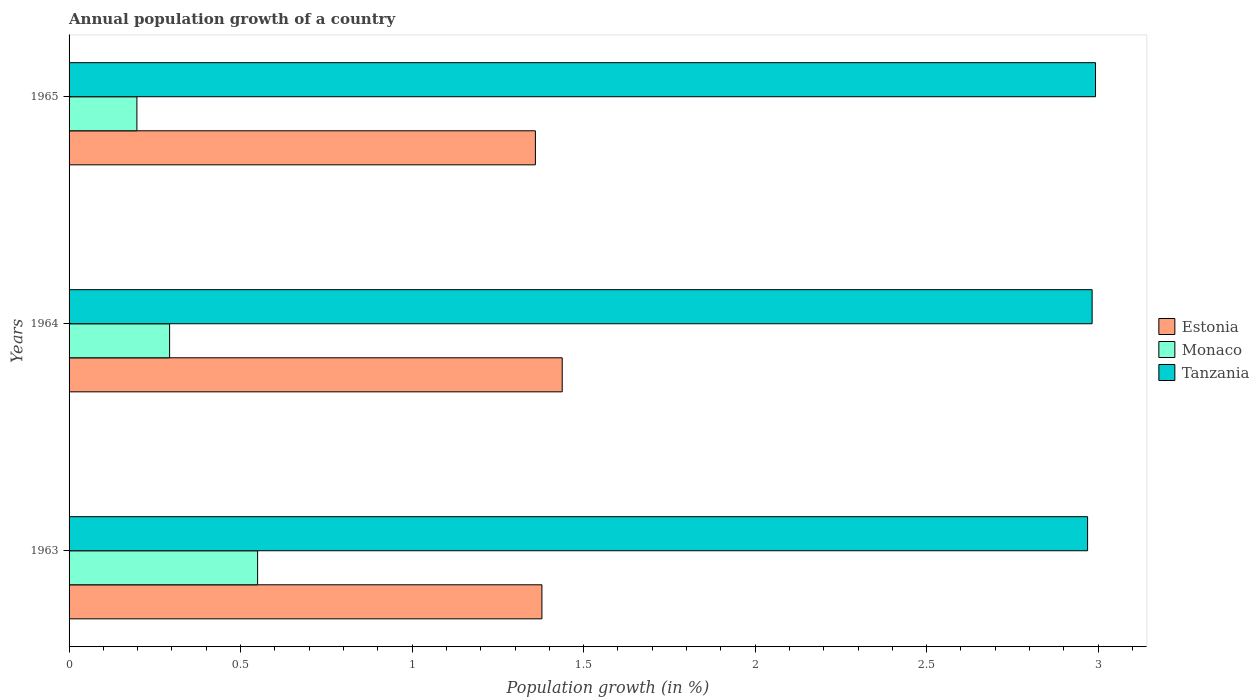How many different coloured bars are there?
Give a very brief answer. 3. How many groups of bars are there?
Give a very brief answer. 3. Are the number of bars per tick equal to the number of legend labels?
Offer a very short reply. Yes. Are the number of bars on each tick of the Y-axis equal?
Ensure brevity in your answer.  Yes. How many bars are there on the 1st tick from the bottom?
Offer a very short reply. 3. What is the label of the 2nd group of bars from the top?
Keep it short and to the point. 1964. In how many cases, is the number of bars for a given year not equal to the number of legend labels?
Ensure brevity in your answer.  0. What is the annual population growth in Estonia in 1965?
Your answer should be compact. 1.36. Across all years, what is the maximum annual population growth in Tanzania?
Offer a terse response. 2.99. Across all years, what is the minimum annual population growth in Monaco?
Offer a terse response. 0.2. In which year was the annual population growth in Estonia maximum?
Keep it short and to the point. 1964. In which year was the annual population growth in Monaco minimum?
Provide a succinct answer. 1965. What is the total annual population growth in Tanzania in the graph?
Make the answer very short. 8.94. What is the difference between the annual population growth in Estonia in 1963 and that in 1965?
Give a very brief answer. 0.02. What is the difference between the annual population growth in Estonia in 1964 and the annual population growth in Monaco in 1963?
Your response must be concise. 0.89. What is the average annual population growth in Estonia per year?
Your response must be concise. 1.39. In the year 1965, what is the difference between the annual population growth in Monaco and annual population growth in Tanzania?
Ensure brevity in your answer.  -2.79. What is the ratio of the annual population growth in Tanzania in 1964 to that in 1965?
Provide a short and direct response. 1. Is the difference between the annual population growth in Monaco in 1964 and 1965 greater than the difference between the annual population growth in Tanzania in 1964 and 1965?
Your response must be concise. Yes. What is the difference between the highest and the second highest annual population growth in Estonia?
Ensure brevity in your answer.  0.06. What is the difference between the highest and the lowest annual population growth in Estonia?
Make the answer very short. 0.08. What does the 2nd bar from the top in 1964 represents?
Ensure brevity in your answer.  Monaco. What does the 2nd bar from the bottom in 1965 represents?
Ensure brevity in your answer.  Monaco. Is it the case that in every year, the sum of the annual population growth in Monaco and annual population growth in Tanzania is greater than the annual population growth in Estonia?
Ensure brevity in your answer.  Yes. How many bars are there?
Your answer should be very brief. 9. What is the difference between two consecutive major ticks on the X-axis?
Ensure brevity in your answer.  0.5. Does the graph contain any zero values?
Offer a very short reply. No. Where does the legend appear in the graph?
Ensure brevity in your answer.  Center right. How many legend labels are there?
Provide a succinct answer. 3. How are the legend labels stacked?
Keep it short and to the point. Vertical. What is the title of the graph?
Keep it short and to the point. Annual population growth of a country. Does "Sao Tome and Principe" appear as one of the legend labels in the graph?
Offer a very short reply. No. What is the label or title of the X-axis?
Provide a succinct answer. Population growth (in %). What is the label or title of the Y-axis?
Give a very brief answer. Years. What is the Population growth (in %) in Estonia in 1963?
Your answer should be compact. 1.38. What is the Population growth (in %) in Monaco in 1963?
Provide a short and direct response. 0.55. What is the Population growth (in %) in Tanzania in 1963?
Your answer should be compact. 2.97. What is the Population growth (in %) of Estonia in 1964?
Provide a short and direct response. 1.44. What is the Population growth (in %) of Monaco in 1964?
Ensure brevity in your answer.  0.29. What is the Population growth (in %) of Tanzania in 1964?
Your response must be concise. 2.98. What is the Population growth (in %) of Estonia in 1965?
Offer a terse response. 1.36. What is the Population growth (in %) of Monaco in 1965?
Provide a short and direct response. 0.2. What is the Population growth (in %) of Tanzania in 1965?
Ensure brevity in your answer.  2.99. Across all years, what is the maximum Population growth (in %) of Estonia?
Give a very brief answer. 1.44. Across all years, what is the maximum Population growth (in %) in Monaco?
Your answer should be very brief. 0.55. Across all years, what is the maximum Population growth (in %) of Tanzania?
Offer a very short reply. 2.99. Across all years, what is the minimum Population growth (in %) of Estonia?
Provide a short and direct response. 1.36. Across all years, what is the minimum Population growth (in %) of Monaco?
Your answer should be compact. 0.2. Across all years, what is the minimum Population growth (in %) of Tanzania?
Your response must be concise. 2.97. What is the total Population growth (in %) of Estonia in the graph?
Provide a succinct answer. 4.18. What is the total Population growth (in %) in Monaco in the graph?
Your answer should be very brief. 1.04. What is the total Population growth (in %) of Tanzania in the graph?
Your answer should be very brief. 8.94. What is the difference between the Population growth (in %) of Estonia in 1963 and that in 1964?
Provide a short and direct response. -0.06. What is the difference between the Population growth (in %) in Monaco in 1963 and that in 1964?
Ensure brevity in your answer.  0.26. What is the difference between the Population growth (in %) in Tanzania in 1963 and that in 1964?
Your answer should be compact. -0.01. What is the difference between the Population growth (in %) of Estonia in 1963 and that in 1965?
Provide a succinct answer. 0.02. What is the difference between the Population growth (in %) in Monaco in 1963 and that in 1965?
Ensure brevity in your answer.  0.35. What is the difference between the Population growth (in %) in Tanzania in 1963 and that in 1965?
Make the answer very short. -0.02. What is the difference between the Population growth (in %) of Estonia in 1964 and that in 1965?
Offer a very short reply. 0.08. What is the difference between the Population growth (in %) of Monaco in 1964 and that in 1965?
Ensure brevity in your answer.  0.1. What is the difference between the Population growth (in %) of Tanzania in 1964 and that in 1965?
Provide a short and direct response. -0.01. What is the difference between the Population growth (in %) in Estonia in 1963 and the Population growth (in %) in Monaco in 1964?
Make the answer very short. 1.09. What is the difference between the Population growth (in %) in Estonia in 1963 and the Population growth (in %) in Tanzania in 1964?
Provide a succinct answer. -1.6. What is the difference between the Population growth (in %) of Monaco in 1963 and the Population growth (in %) of Tanzania in 1964?
Ensure brevity in your answer.  -2.43. What is the difference between the Population growth (in %) of Estonia in 1963 and the Population growth (in %) of Monaco in 1965?
Give a very brief answer. 1.18. What is the difference between the Population growth (in %) in Estonia in 1963 and the Population growth (in %) in Tanzania in 1965?
Your answer should be compact. -1.61. What is the difference between the Population growth (in %) in Monaco in 1963 and the Population growth (in %) in Tanzania in 1965?
Make the answer very short. -2.44. What is the difference between the Population growth (in %) of Estonia in 1964 and the Population growth (in %) of Monaco in 1965?
Give a very brief answer. 1.24. What is the difference between the Population growth (in %) in Estonia in 1964 and the Population growth (in %) in Tanzania in 1965?
Ensure brevity in your answer.  -1.55. What is the difference between the Population growth (in %) in Monaco in 1964 and the Population growth (in %) in Tanzania in 1965?
Your response must be concise. -2.7. What is the average Population growth (in %) in Estonia per year?
Make the answer very short. 1.39. What is the average Population growth (in %) of Monaco per year?
Offer a very short reply. 0.35. What is the average Population growth (in %) of Tanzania per year?
Your answer should be very brief. 2.98. In the year 1963, what is the difference between the Population growth (in %) in Estonia and Population growth (in %) in Monaco?
Keep it short and to the point. 0.83. In the year 1963, what is the difference between the Population growth (in %) in Estonia and Population growth (in %) in Tanzania?
Offer a very short reply. -1.59. In the year 1963, what is the difference between the Population growth (in %) of Monaco and Population growth (in %) of Tanzania?
Offer a very short reply. -2.42. In the year 1964, what is the difference between the Population growth (in %) of Estonia and Population growth (in %) of Monaco?
Keep it short and to the point. 1.14. In the year 1964, what is the difference between the Population growth (in %) in Estonia and Population growth (in %) in Tanzania?
Your answer should be very brief. -1.54. In the year 1964, what is the difference between the Population growth (in %) of Monaco and Population growth (in %) of Tanzania?
Keep it short and to the point. -2.69. In the year 1965, what is the difference between the Population growth (in %) of Estonia and Population growth (in %) of Monaco?
Make the answer very short. 1.16. In the year 1965, what is the difference between the Population growth (in %) in Estonia and Population growth (in %) in Tanzania?
Give a very brief answer. -1.63. In the year 1965, what is the difference between the Population growth (in %) of Monaco and Population growth (in %) of Tanzania?
Offer a terse response. -2.79. What is the ratio of the Population growth (in %) of Estonia in 1963 to that in 1964?
Your answer should be compact. 0.96. What is the ratio of the Population growth (in %) of Monaco in 1963 to that in 1964?
Provide a short and direct response. 1.88. What is the ratio of the Population growth (in %) of Tanzania in 1963 to that in 1964?
Your answer should be very brief. 1. What is the ratio of the Population growth (in %) in Estonia in 1963 to that in 1965?
Make the answer very short. 1.01. What is the ratio of the Population growth (in %) in Monaco in 1963 to that in 1965?
Keep it short and to the point. 2.78. What is the ratio of the Population growth (in %) of Estonia in 1964 to that in 1965?
Give a very brief answer. 1.06. What is the ratio of the Population growth (in %) of Monaco in 1964 to that in 1965?
Provide a short and direct response. 1.48. What is the ratio of the Population growth (in %) of Tanzania in 1964 to that in 1965?
Provide a succinct answer. 1. What is the difference between the highest and the second highest Population growth (in %) in Estonia?
Ensure brevity in your answer.  0.06. What is the difference between the highest and the second highest Population growth (in %) of Monaco?
Your answer should be compact. 0.26. What is the difference between the highest and the second highest Population growth (in %) in Tanzania?
Offer a terse response. 0.01. What is the difference between the highest and the lowest Population growth (in %) of Estonia?
Offer a terse response. 0.08. What is the difference between the highest and the lowest Population growth (in %) in Monaco?
Make the answer very short. 0.35. What is the difference between the highest and the lowest Population growth (in %) of Tanzania?
Provide a short and direct response. 0.02. 